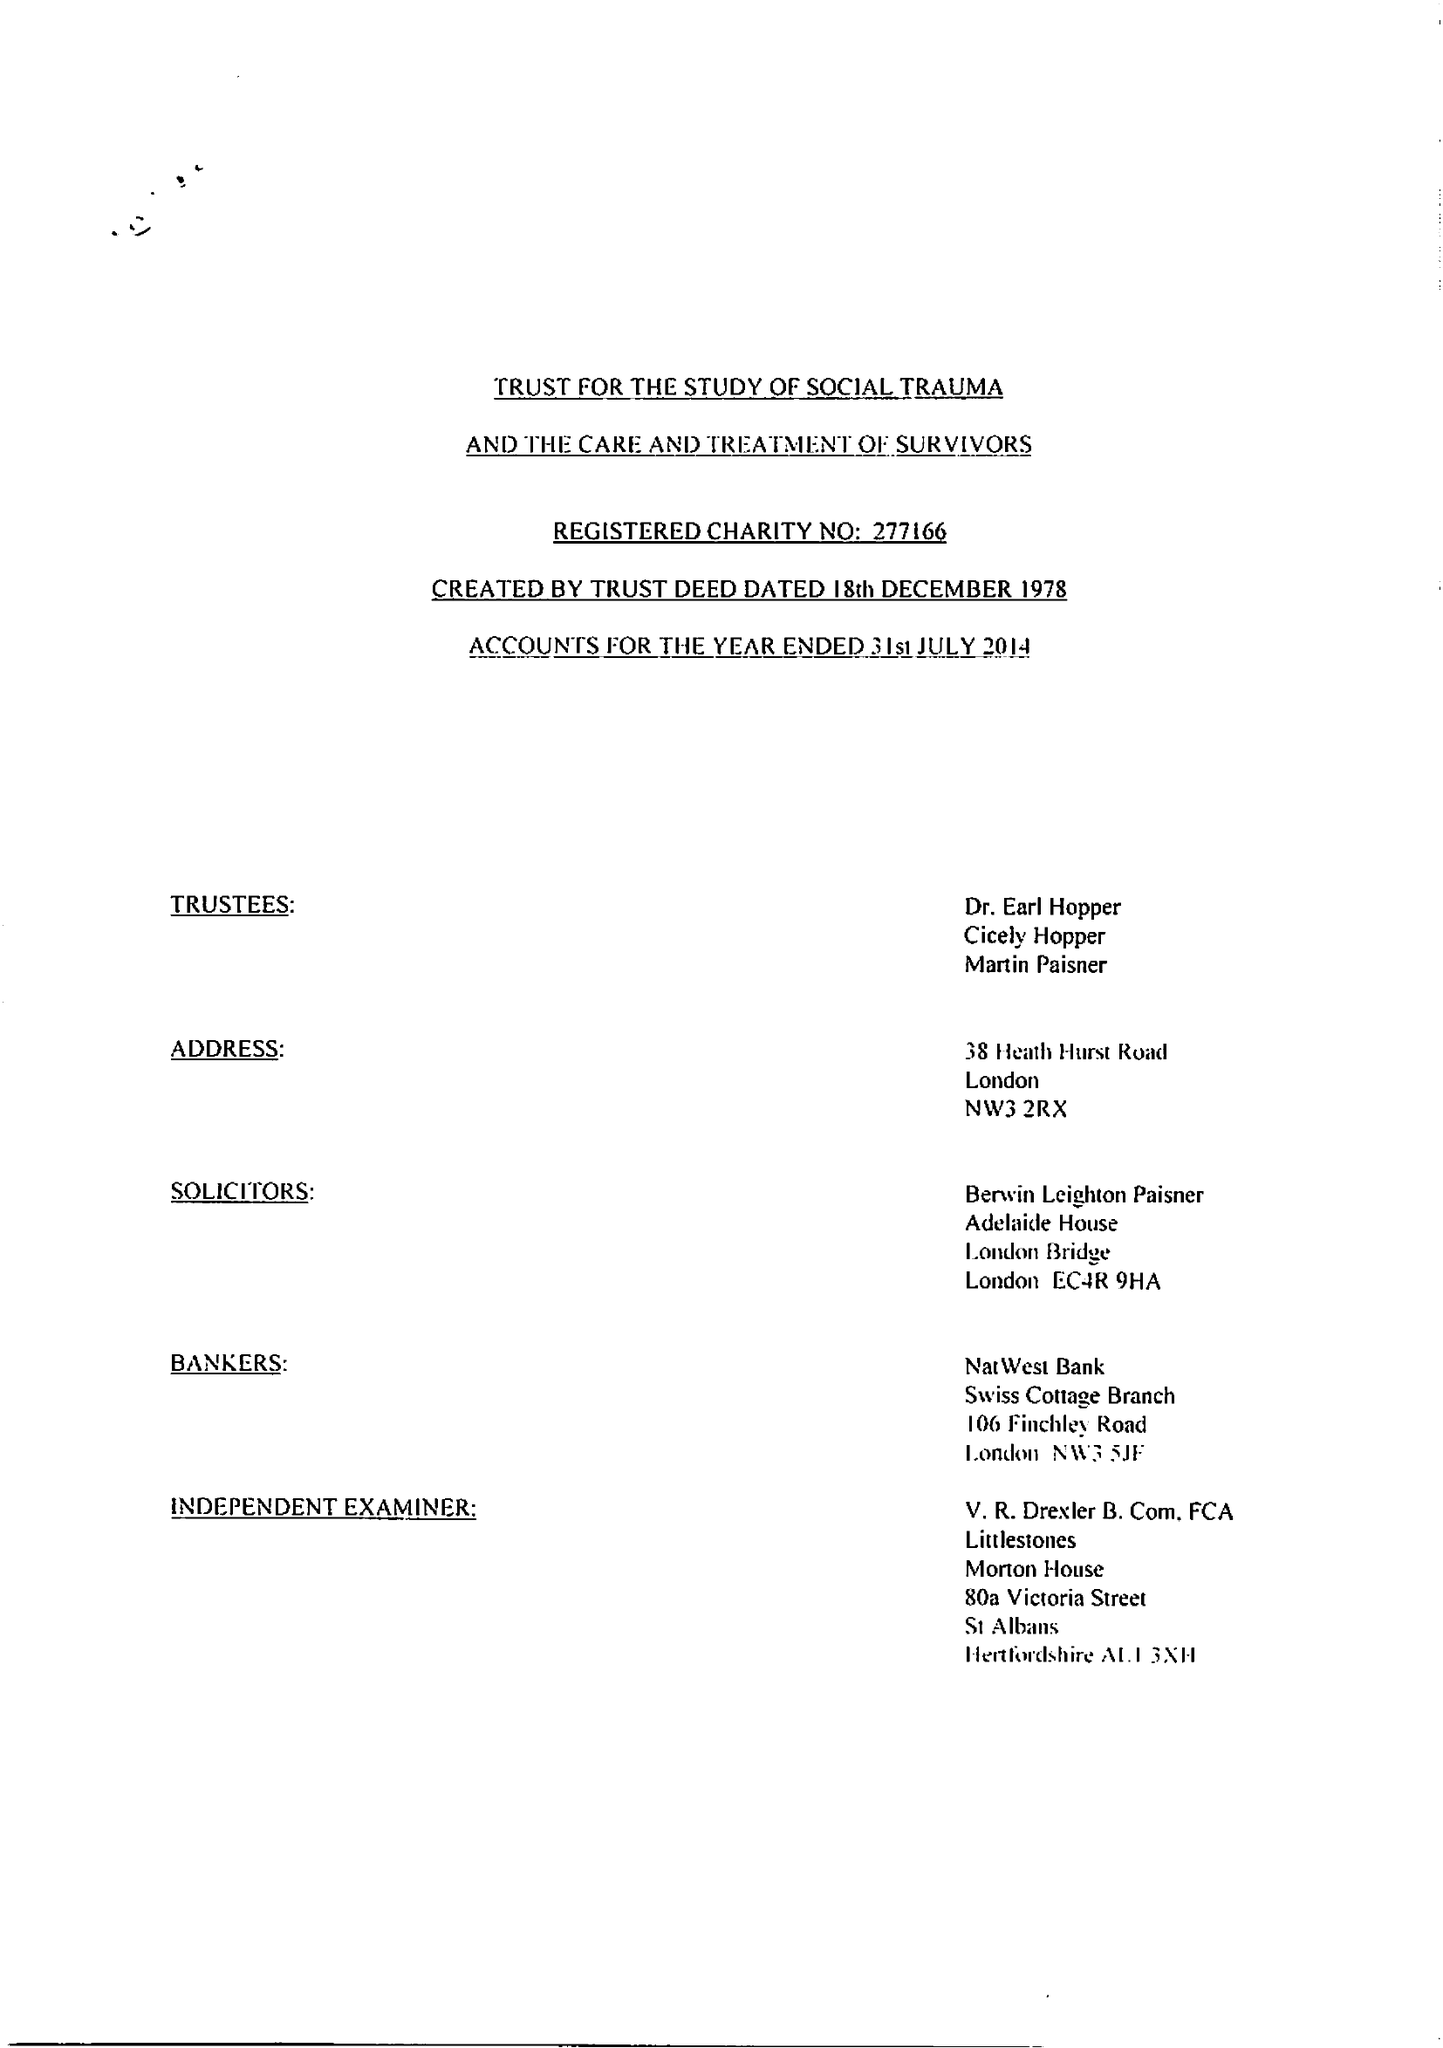What is the value for the charity_number?
Answer the question using a single word or phrase. 277166 